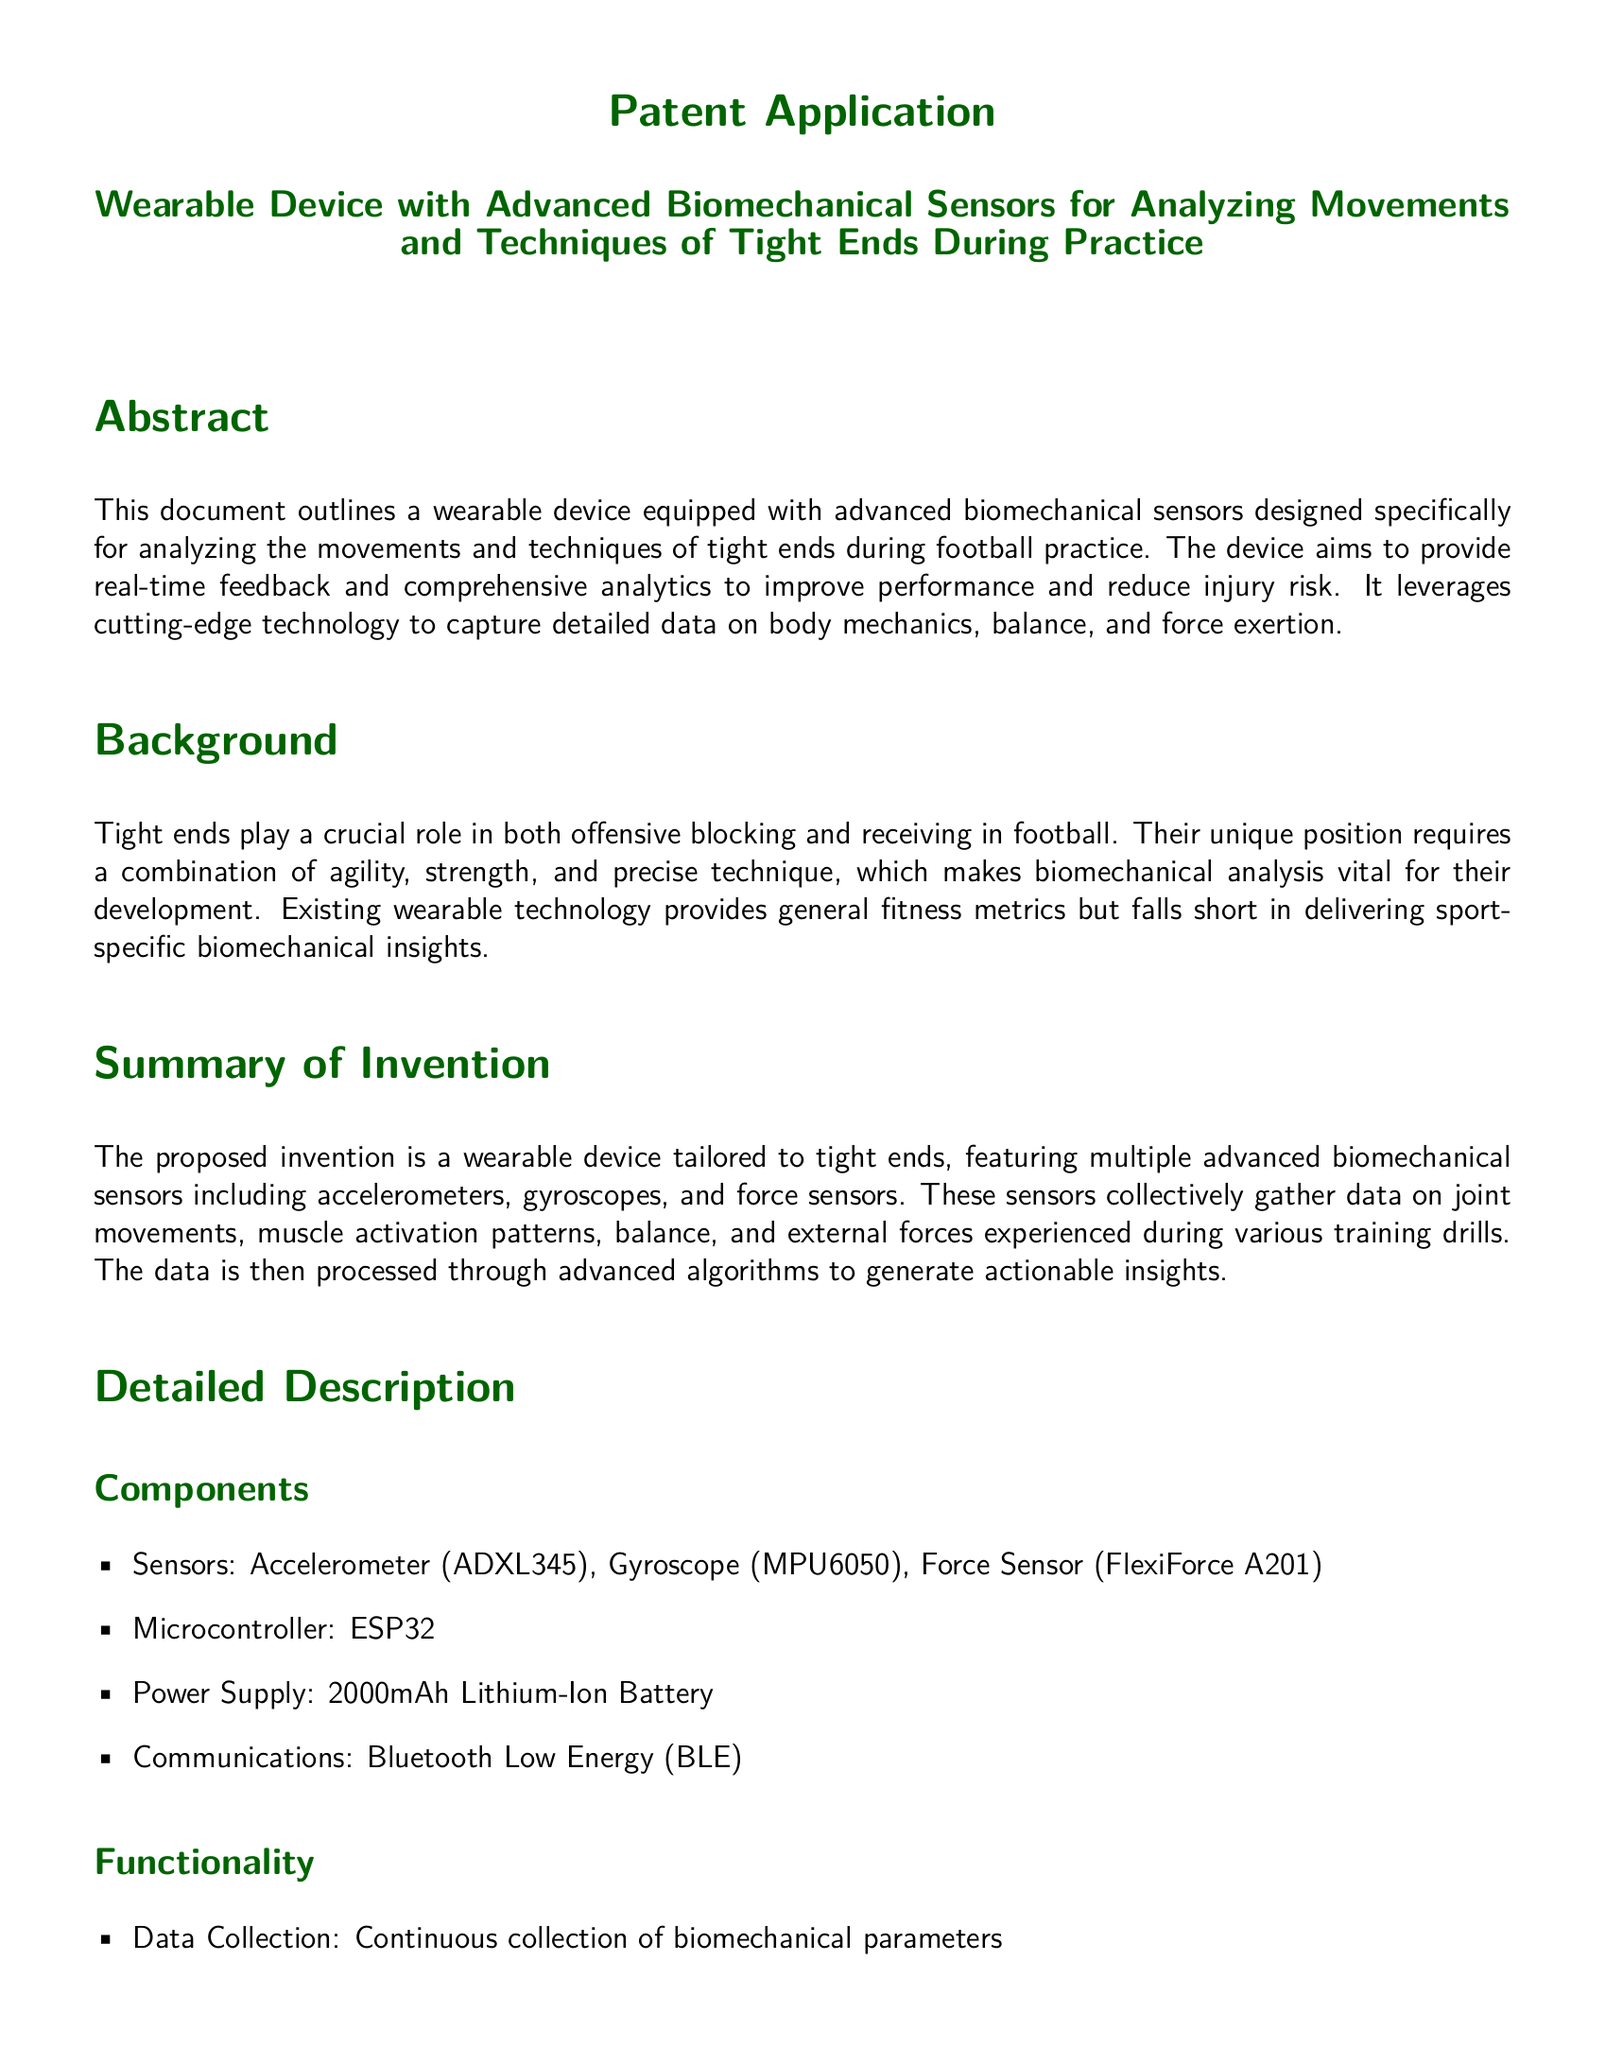What is the primary focus of the invention? The invention focuses on a wearable device designed to analyze movements and techniques of tight ends during football practice.
Answer: wearable device Which sensors are included in the proposed device? The document lists three types of sensors used in the device: an accelerometer, a gyroscope, and a force sensor.
Answer: accelerometer, gyroscope, force sensor What technology does the device use for communication? The device uses Bluetooth Low Energy for communication.
Answer: Bluetooth Low Energy What is the power supply of the device? The document states that the device uses a 2000mAh Lithium-Ion Battery as its power supply.
Answer: 2000mAh Lithium-Ion Battery What key advantage does the device provide for tight ends? The key advantage mentioned is performance enhancement through comprehensive analytics for technique refinement.
Answer: performance enhancement Which teams might benefit from this device? Potential applications listed in the document include professional football teams and college football programs.
Answer: professional football teams, college football programs What does the device analyze to prevent injury? The device analyzes joint and muscle stress to help in injury prevention.
Answer: joint and muscle stress What is the design of the device described as? The document describes the design of the device as lightweight and non-intrusive.
Answer: lightweight and non-intrusive What type of document is this? This is a patent application outlining a new invention related to sports technology.
Answer: patent application 